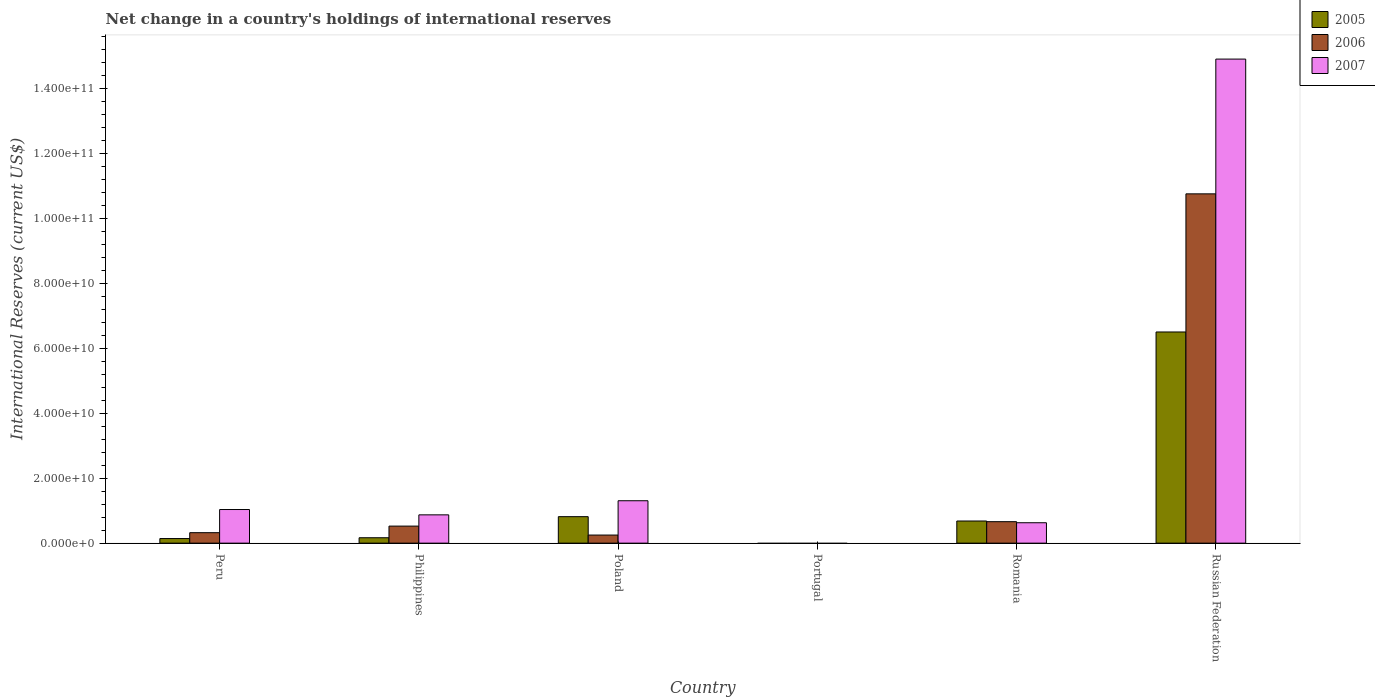How many different coloured bars are there?
Provide a succinct answer. 3. Are the number of bars on each tick of the X-axis equal?
Provide a succinct answer. No. How many bars are there on the 5th tick from the right?
Keep it short and to the point. 3. In how many cases, is the number of bars for a given country not equal to the number of legend labels?
Give a very brief answer. 1. What is the international reserves in 2007 in Romania?
Give a very brief answer. 6.28e+09. Across all countries, what is the maximum international reserves in 2007?
Provide a succinct answer. 1.49e+11. In which country was the international reserves in 2007 maximum?
Keep it short and to the point. Russian Federation. What is the total international reserves in 2007 in the graph?
Your response must be concise. 1.87e+11. What is the difference between the international reserves in 2007 in Peru and that in Russian Federation?
Provide a succinct answer. -1.39e+11. What is the difference between the international reserves in 2006 in Peru and the international reserves in 2007 in Romania?
Give a very brief answer. -3.06e+09. What is the average international reserves in 2007 per country?
Make the answer very short. 3.12e+1. What is the difference between the international reserves of/in 2006 and international reserves of/in 2007 in Philippines?
Ensure brevity in your answer.  -3.46e+09. In how many countries, is the international reserves in 2006 greater than 28000000000 US$?
Your answer should be compact. 1. What is the ratio of the international reserves in 2005 in Peru to that in Poland?
Your answer should be compact. 0.17. Is the international reserves in 2006 in Peru less than that in Romania?
Your response must be concise. Yes. What is the difference between the highest and the second highest international reserves in 2005?
Provide a short and direct response. 5.82e+1. What is the difference between the highest and the lowest international reserves in 2006?
Give a very brief answer. 1.07e+11. Is the sum of the international reserves in 2006 in Poland and Romania greater than the maximum international reserves in 2007 across all countries?
Provide a succinct answer. No. What is the difference between two consecutive major ticks on the Y-axis?
Make the answer very short. 2.00e+1. Are the values on the major ticks of Y-axis written in scientific E-notation?
Give a very brief answer. Yes. Does the graph contain any zero values?
Provide a short and direct response. Yes. Does the graph contain grids?
Provide a succinct answer. No. Where does the legend appear in the graph?
Offer a very short reply. Top right. How many legend labels are there?
Give a very brief answer. 3. What is the title of the graph?
Provide a short and direct response. Net change in a country's holdings of international reserves. What is the label or title of the X-axis?
Your answer should be compact. Country. What is the label or title of the Y-axis?
Give a very brief answer. International Reserves (current US$). What is the International Reserves (current US$) of 2005 in Peru?
Provide a short and direct response. 1.41e+09. What is the International Reserves (current US$) in 2006 in Peru?
Provide a short and direct response. 3.22e+09. What is the International Reserves (current US$) in 2007 in Peru?
Offer a terse response. 1.03e+1. What is the International Reserves (current US$) in 2005 in Philippines?
Offer a very short reply. 1.66e+09. What is the International Reserves (current US$) of 2006 in Philippines?
Your answer should be very brief. 5.24e+09. What is the International Reserves (current US$) in 2007 in Philippines?
Your answer should be very brief. 8.71e+09. What is the International Reserves (current US$) in 2005 in Poland?
Provide a succinct answer. 8.15e+09. What is the International Reserves (current US$) of 2006 in Poland?
Your answer should be compact. 2.49e+09. What is the International Reserves (current US$) of 2007 in Poland?
Provide a short and direct response. 1.30e+1. What is the International Reserves (current US$) of 2007 in Portugal?
Your response must be concise. 0. What is the International Reserves (current US$) of 2005 in Romania?
Make the answer very short. 6.81e+09. What is the International Reserves (current US$) of 2006 in Romania?
Ensure brevity in your answer.  6.60e+09. What is the International Reserves (current US$) of 2007 in Romania?
Ensure brevity in your answer.  6.28e+09. What is the International Reserves (current US$) of 2005 in Russian Federation?
Your response must be concise. 6.50e+1. What is the International Reserves (current US$) of 2006 in Russian Federation?
Offer a terse response. 1.07e+11. What is the International Reserves (current US$) in 2007 in Russian Federation?
Give a very brief answer. 1.49e+11. Across all countries, what is the maximum International Reserves (current US$) of 2005?
Your response must be concise. 6.50e+1. Across all countries, what is the maximum International Reserves (current US$) in 2006?
Make the answer very short. 1.07e+11. Across all countries, what is the maximum International Reserves (current US$) in 2007?
Your answer should be compact. 1.49e+11. Across all countries, what is the minimum International Reserves (current US$) of 2006?
Ensure brevity in your answer.  0. Across all countries, what is the minimum International Reserves (current US$) of 2007?
Offer a terse response. 0. What is the total International Reserves (current US$) in 2005 in the graph?
Offer a very short reply. 8.30e+1. What is the total International Reserves (current US$) in 2006 in the graph?
Your answer should be compact. 1.25e+11. What is the total International Reserves (current US$) of 2007 in the graph?
Provide a short and direct response. 1.87e+11. What is the difference between the International Reserves (current US$) of 2005 in Peru and that in Philippines?
Keep it short and to the point. -2.51e+08. What is the difference between the International Reserves (current US$) in 2006 in Peru and that in Philippines?
Provide a short and direct response. -2.02e+09. What is the difference between the International Reserves (current US$) of 2007 in Peru and that in Philippines?
Your response must be concise. 1.64e+09. What is the difference between the International Reserves (current US$) in 2005 in Peru and that in Poland?
Your answer should be very brief. -6.73e+09. What is the difference between the International Reserves (current US$) in 2006 in Peru and that in Poland?
Ensure brevity in your answer.  7.33e+08. What is the difference between the International Reserves (current US$) of 2007 in Peru and that in Poland?
Offer a terse response. -2.70e+09. What is the difference between the International Reserves (current US$) of 2005 in Peru and that in Romania?
Give a very brief answer. -5.40e+09. What is the difference between the International Reserves (current US$) of 2006 in Peru and that in Romania?
Your answer should be very brief. -3.38e+09. What is the difference between the International Reserves (current US$) of 2007 in Peru and that in Romania?
Make the answer very short. 4.06e+09. What is the difference between the International Reserves (current US$) in 2005 in Peru and that in Russian Federation?
Your answer should be very brief. -6.36e+1. What is the difference between the International Reserves (current US$) of 2006 in Peru and that in Russian Federation?
Your answer should be compact. -1.04e+11. What is the difference between the International Reserves (current US$) of 2007 in Peru and that in Russian Federation?
Your answer should be very brief. -1.39e+11. What is the difference between the International Reserves (current US$) in 2005 in Philippines and that in Poland?
Provide a short and direct response. -6.48e+09. What is the difference between the International Reserves (current US$) in 2006 in Philippines and that in Poland?
Make the answer very short. 2.75e+09. What is the difference between the International Reserves (current US$) in 2007 in Philippines and that in Poland?
Your answer should be compact. -4.34e+09. What is the difference between the International Reserves (current US$) of 2005 in Philippines and that in Romania?
Your answer should be compact. -5.15e+09. What is the difference between the International Reserves (current US$) in 2006 in Philippines and that in Romania?
Offer a very short reply. -1.36e+09. What is the difference between the International Reserves (current US$) of 2007 in Philippines and that in Romania?
Provide a short and direct response. 2.43e+09. What is the difference between the International Reserves (current US$) of 2005 in Philippines and that in Russian Federation?
Ensure brevity in your answer.  -6.33e+1. What is the difference between the International Reserves (current US$) of 2006 in Philippines and that in Russian Federation?
Ensure brevity in your answer.  -1.02e+11. What is the difference between the International Reserves (current US$) in 2007 in Philippines and that in Russian Federation?
Give a very brief answer. -1.40e+11. What is the difference between the International Reserves (current US$) in 2005 in Poland and that in Romania?
Your response must be concise. 1.34e+09. What is the difference between the International Reserves (current US$) in 2006 in Poland and that in Romania?
Keep it short and to the point. -4.11e+09. What is the difference between the International Reserves (current US$) of 2007 in Poland and that in Romania?
Provide a short and direct response. 6.76e+09. What is the difference between the International Reserves (current US$) in 2005 in Poland and that in Russian Federation?
Make the answer very short. -5.68e+1. What is the difference between the International Reserves (current US$) in 2006 in Poland and that in Russian Federation?
Make the answer very short. -1.05e+11. What is the difference between the International Reserves (current US$) in 2007 in Poland and that in Russian Federation?
Offer a very short reply. -1.36e+11. What is the difference between the International Reserves (current US$) in 2005 in Romania and that in Russian Federation?
Your answer should be compact. -5.82e+1. What is the difference between the International Reserves (current US$) of 2006 in Romania and that in Russian Federation?
Your response must be concise. -1.01e+11. What is the difference between the International Reserves (current US$) in 2007 in Romania and that in Russian Federation?
Offer a very short reply. -1.43e+11. What is the difference between the International Reserves (current US$) of 2005 in Peru and the International Reserves (current US$) of 2006 in Philippines?
Provide a short and direct response. -3.83e+09. What is the difference between the International Reserves (current US$) of 2005 in Peru and the International Reserves (current US$) of 2007 in Philippines?
Ensure brevity in your answer.  -7.29e+09. What is the difference between the International Reserves (current US$) of 2006 in Peru and the International Reserves (current US$) of 2007 in Philippines?
Offer a very short reply. -5.48e+09. What is the difference between the International Reserves (current US$) in 2005 in Peru and the International Reserves (current US$) in 2006 in Poland?
Your answer should be very brief. -1.08e+09. What is the difference between the International Reserves (current US$) of 2005 in Peru and the International Reserves (current US$) of 2007 in Poland?
Provide a succinct answer. -1.16e+1. What is the difference between the International Reserves (current US$) of 2006 in Peru and the International Reserves (current US$) of 2007 in Poland?
Your answer should be very brief. -9.82e+09. What is the difference between the International Reserves (current US$) of 2005 in Peru and the International Reserves (current US$) of 2006 in Romania?
Give a very brief answer. -5.19e+09. What is the difference between the International Reserves (current US$) of 2005 in Peru and the International Reserves (current US$) of 2007 in Romania?
Your answer should be compact. -4.87e+09. What is the difference between the International Reserves (current US$) of 2006 in Peru and the International Reserves (current US$) of 2007 in Romania?
Offer a terse response. -3.06e+09. What is the difference between the International Reserves (current US$) in 2005 in Peru and the International Reserves (current US$) in 2006 in Russian Federation?
Your answer should be very brief. -1.06e+11. What is the difference between the International Reserves (current US$) in 2005 in Peru and the International Reserves (current US$) in 2007 in Russian Federation?
Offer a terse response. -1.48e+11. What is the difference between the International Reserves (current US$) of 2006 in Peru and the International Reserves (current US$) of 2007 in Russian Federation?
Make the answer very short. -1.46e+11. What is the difference between the International Reserves (current US$) in 2005 in Philippines and the International Reserves (current US$) in 2006 in Poland?
Your response must be concise. -8.27e+08. What is the difference between the International Reserves (current US$) in 2005 in Philippines and the International Reserves (current US$) in 2007 in Poland?
Keep it short and to the point. -1.14e+1. What is the difference between the International Reserves (current US$) of 2006 in Philippines and the International Reserves (current US$) of 2007 in Poland?
Your answer should be very brief. -7.80e+09. What is the difference between the International Reserves (current US$) of 2005 in Philippines and the International Reserves (current US$) of 2006 in Romania?
Your answer should be compact. -4.94e+09. What is the difference between the International Reserves (current US$) of 2005 in Philippines and the International Reserves (current US$) of 2007 in Romania?
Make the answer very short. -4.62e+09. What is the difference between the International Reserves (current US$) of 2006 in Philippines and the International Reserves (current US$) of 2007 in Romania?
Your response must be concise. -1.04e+09. What is the difference between the International Reserves (current US$) of 2005 in Philippines and the International Reserves (current US$) of 2006 in Russian Federation?
Offer a very short reply. -1.06e+11. What is the difference between the International Reserves (current US$) in 2005 in Philippines and the International Reserves (current US$) in 2007 in Russian Federation?
Provide a short and direct response. -1.47e+11. What is the difference between the International Reserves (current US$) in 2006 in Philippines and the International Reserves (current US$) in 2007 in Russian Federation?
Provide a succinct answer. -1.44e+11. What is the difference between the International Reserves (current US$) of 2005 in Poland and the International Reserves (current US$) of 2006 in Romania?
Ensure brevity in your answer.  1.54e+09. What is the difference between the International Reserves (current US$) in 2005 in Poland and the International Reserves (current US$) in 2007 in Romania?
Make the answer very short. 1.87e+09. What is the difference between the International Reserves (current US$) in 2006 in Poland and the International Reserves (current US$) in 2007 in Romania?
Offer a terse response. -3.79e+09. What is the difference between the International Reserves (current US$) of 2005 in Poland and the International Reserves (current US$) of 2006 in Russian Federation?
Ensure brevity in your answer.  -9.93e+1. What is the difference between the International Reserves (current US$) of 2005 in Poland and the International Reserves (current US$) of 2007 in Russian Federation?
Your response must be concise. -1.41e+11. What is the difference between the International Reserves (current US$) in 2006 in Poland and the International Reserves (current US$) in 2007 in Russian Federation?
Make the answer very short. -1.46e+11. What is the difference between the International Reserves (current US$) in 2005 in Romania and the International Reserves (current US$) in 2006 in Russian Federation?
Provide a short and direct response. -1.01e+11. What is the difference between the International Reserves (current US$) in 2005 in Romania and the International Reserves (current US$) in 2007 in Russian Federation?
Provide a succinct answer. -1.42e+11. What is the difference between the International Reserves (current US$) in 2006 in Romania and the International Reserves (current US$) in 2007 in Russian Federation?
Your answer should be very brief. -1.42e+11. What is the average International Reserves (current US$) of 2005 per country?
Keep it short and to the point. 1.38e+1. What is the average International Reserves (current US$) in 2006 per country?
Make the answer very short. 2.08e+1. What is the average International Reserves (current US$) of 2007 per country?
Offer a terse response. 3.12e+1. What is the difference between the International Reserves (current US$) of 2005 and International Reserves (current US$) of 2006 in Peru?
Make the answer very short. -1.81e+09. What is the difference between the International Reserves (current US$) in 2005 and International Reserves (current US$) in 2007 in Peru?
Give a very brief answer. -8.93e+09. What is the difference between the International Reserves (current US$) in 2006 and International Reserves (current US$) in 2007 in Peru?
Keep it short and to the point. -7.12e+09. What is the difference between the International Reserves (current US$) in 2005 and International Reserves (current US$) in 2006 in Philippines?
Ensure brevity in your answer.  -3.58e+09. What is the difference between the International Reserves (current US$) in 2005 and International Reserves (current US$) in 2007 in Philippines?
Offer a very short reply. -7.04e+09. What is the difference between the International Reserves (current US$) in 2006 and International Reserves (current US$) in 2007 in Philippines?
Provide a short and direct response. -3.46e+09. What is the difference between the International Reserves (current US$) in 2005 and International Reserves (current US$) in 2006 in Poland?
Your answer should be very brief. 5.66e+09. What is the difference between the International Reserves (current US$) in 2005 and International Reserves (current US$) in 2007 in Poland?
Keep it short and to the point. -4.90e+09. What is the difference between the International Reserves (current US$) in 2006 and International Reserves (current US$) in 2007 in Poland?
Provide a succinct answer. -1.06e+1. What is the difference between the International Reserves (current US$) of 2005 and International Reserves (current US$) of 2006 in Romania?
Offer a very short reply. 2.09e+08. What is the difference between the International Reserves (current US$) in 2005 and International Reserves (current US$) in 2007 in Romania?
Provide a short and direct response. 5.32e+08. What is the difference between the International Reserves (current US$) in 2006 and International Reserves (current US$) in 2007 in Romania?
Ensure brevity in your answer.  3.23e+08. What is the difference between the International Reserves (current US$) in 2005 and International Reserves (current US$) in 2006 in Russian Federation?
Your answer should be compact. -4.25e+1. What is the difference between the International Reserves (current US$) of 2005 and International Reserves (current US$) of 2007 in Russian Federation?
Offer a very short reply. -8.40e+1. What is the difference between the International Reserves (current US$) of 2006 and International Reserves (current US$) of 2007 in Russian Federation?
Offer a terse response. -4.15e+1. What is the ratio of the International Reserves (current US$) of 2005 in Peru to that in Philippines?
Offer a very short reply. 0.85. What is the ratio of the International Reserves (current US$) of 2006 in Peru to that in Philippines?
Your answer should be very brief. 0.61. What is the ratio of the International Reserves (current US$) of 2007 in Peru to that in Philippines?
Offer a terse response. 1.19. What is the ratio of the International Reserves (current US$) in 2005 in Peru to that in Poland?
Keep it short and to the point. 0.17. What is the ratio of the International Reserves (current US$) in 2006 in Peru to that in Poland?
Make the answer very short. 1.29. What is the ratio of the International Reserves (current US$) of 2007 in Peru to that in Poland?
Your answer should be very brief. 0.79. What is the ratio of the International Reserves (current US$) in 2005 in Peru to that in Romania?
Your response must be concise. 0.21. What is the ratio of the International Reserves (current US$) of 2006 in Peru to that in Romania?
Ensure brevity in your answer.  0.49. What is the ratio of the International Reserves (current US$) in 2007 in Peru to that in Romania?
Provide a short and direct response. 1.65. What is the ratio of the International Reserves (current US$) of 2005 in Peru to that in Russian Federation?
Make the answer very short. 0.02. What is the ratio of the International Reserves (current US$) of 2007 in Peru to that in Russian Federation?
Provide a short and direct response. 0.07. What is the ratio of the International Reserves (current US$) of 2005 in Philippines to that in Poland?
Ensure brevity in your answer.  0.2. What is the ratio of the International Reserves (current US$) of 2006 in Philippines to that in Poland?
Provide a succinct answer. 2.11. What is the ratio of the International Reserves (current US$) of 2007 in Philippines to that in Poland?
Ensure brevity in your answer.  0.67. What is the ratio of the International Reserves (current US$) in 2005 in Philippines to that in Romania?
Provide a succinct answer. 0.24. What is the ratio of the International Reserves (current US$) of 2006 in Philippines to that in Romania?
Your response must be concise. 0.79. What is the ratio of the International Reserves (current US$) of 2007 in Philippines to that in Romania?
Offer a terse response. 1.39. What is the ratio of the International Reserves (current US$) in 2005 in Philippines to that in Russian Federation?
Provide a succinct answer. 0.03. What is the ratio of the International Reserves (current US$) in 2006 in Philippines to that in Russian Federation?
Your answer should be compact. 0.05. What is the ratio of the International Reserves (current US$) in 2007 in Philippines to that in Russian Federation?
Offer a very short reply. 0.06. What is the ratio of the International Reserves (current US$) in 2005 in Poland to that in Romania?
Your answer should be compact. 1.2. What is the ratio of the International Reserves (current US$) in 2006 in Poland to that in Romania?
Make the answer very short. 0.38. What is the ratio of the International Reserves (current US$) in 2007 in Poland to that in Romania?
Give a very brief answer. 2.08. What is the ratio of the International Reserves (current US$) of 2005 in Poland to that in Russian Federation?
Offer a terse response. 0.13. What is the ratio of the International Reserves (current US$) in 2006 in Poland to that in Russian Federation?
Offer a very short reply. 0.02. What is the ratio of the International Reserves (current US$) of 2007 in Poland to that in Russian Federation?
Offer a very short reply. 0.09. What is the ratio of the International Reserves (current US$) of 2005 in Romania to that in Russian Federation?
Your response must be concise. 0.1. What is the ratio of the International Reserves (current US$) of 2006 in Romania to that in Russian Federation?
Provide a short and direct response. 0.06. What is the ratio of the International Reserves (current US$) in 2007 in Romania to that in Russian Federation?
Offer a very short reply. 0.04. What is the difference between the highest and the second highest International Reserves (current US$) in 2005?
Ensure brevity in your answer.  5.68e+1. What is the difference between the highest and the second highest International Reserves (current US$) of 2006?
Ensure brevity in your answer.  1.01e+11. What is the difference between the highest and the second highest International Reserves (current US$) of 2007?
Your response must be concise. 1.36e+11. What is the difference between the highest and the lowest International Reserves (current US$) in 2005?
Offer a very short reply. 6.50e+1. What is the difference between the highest and the lowest International Reserves (current US$) in 2006?
Your answer should be compact. 1.07e+11. What is the difference between the highest and the lowest International Reserves (current US$) of 2007?
Make the answer very short. 1.49e+11. 